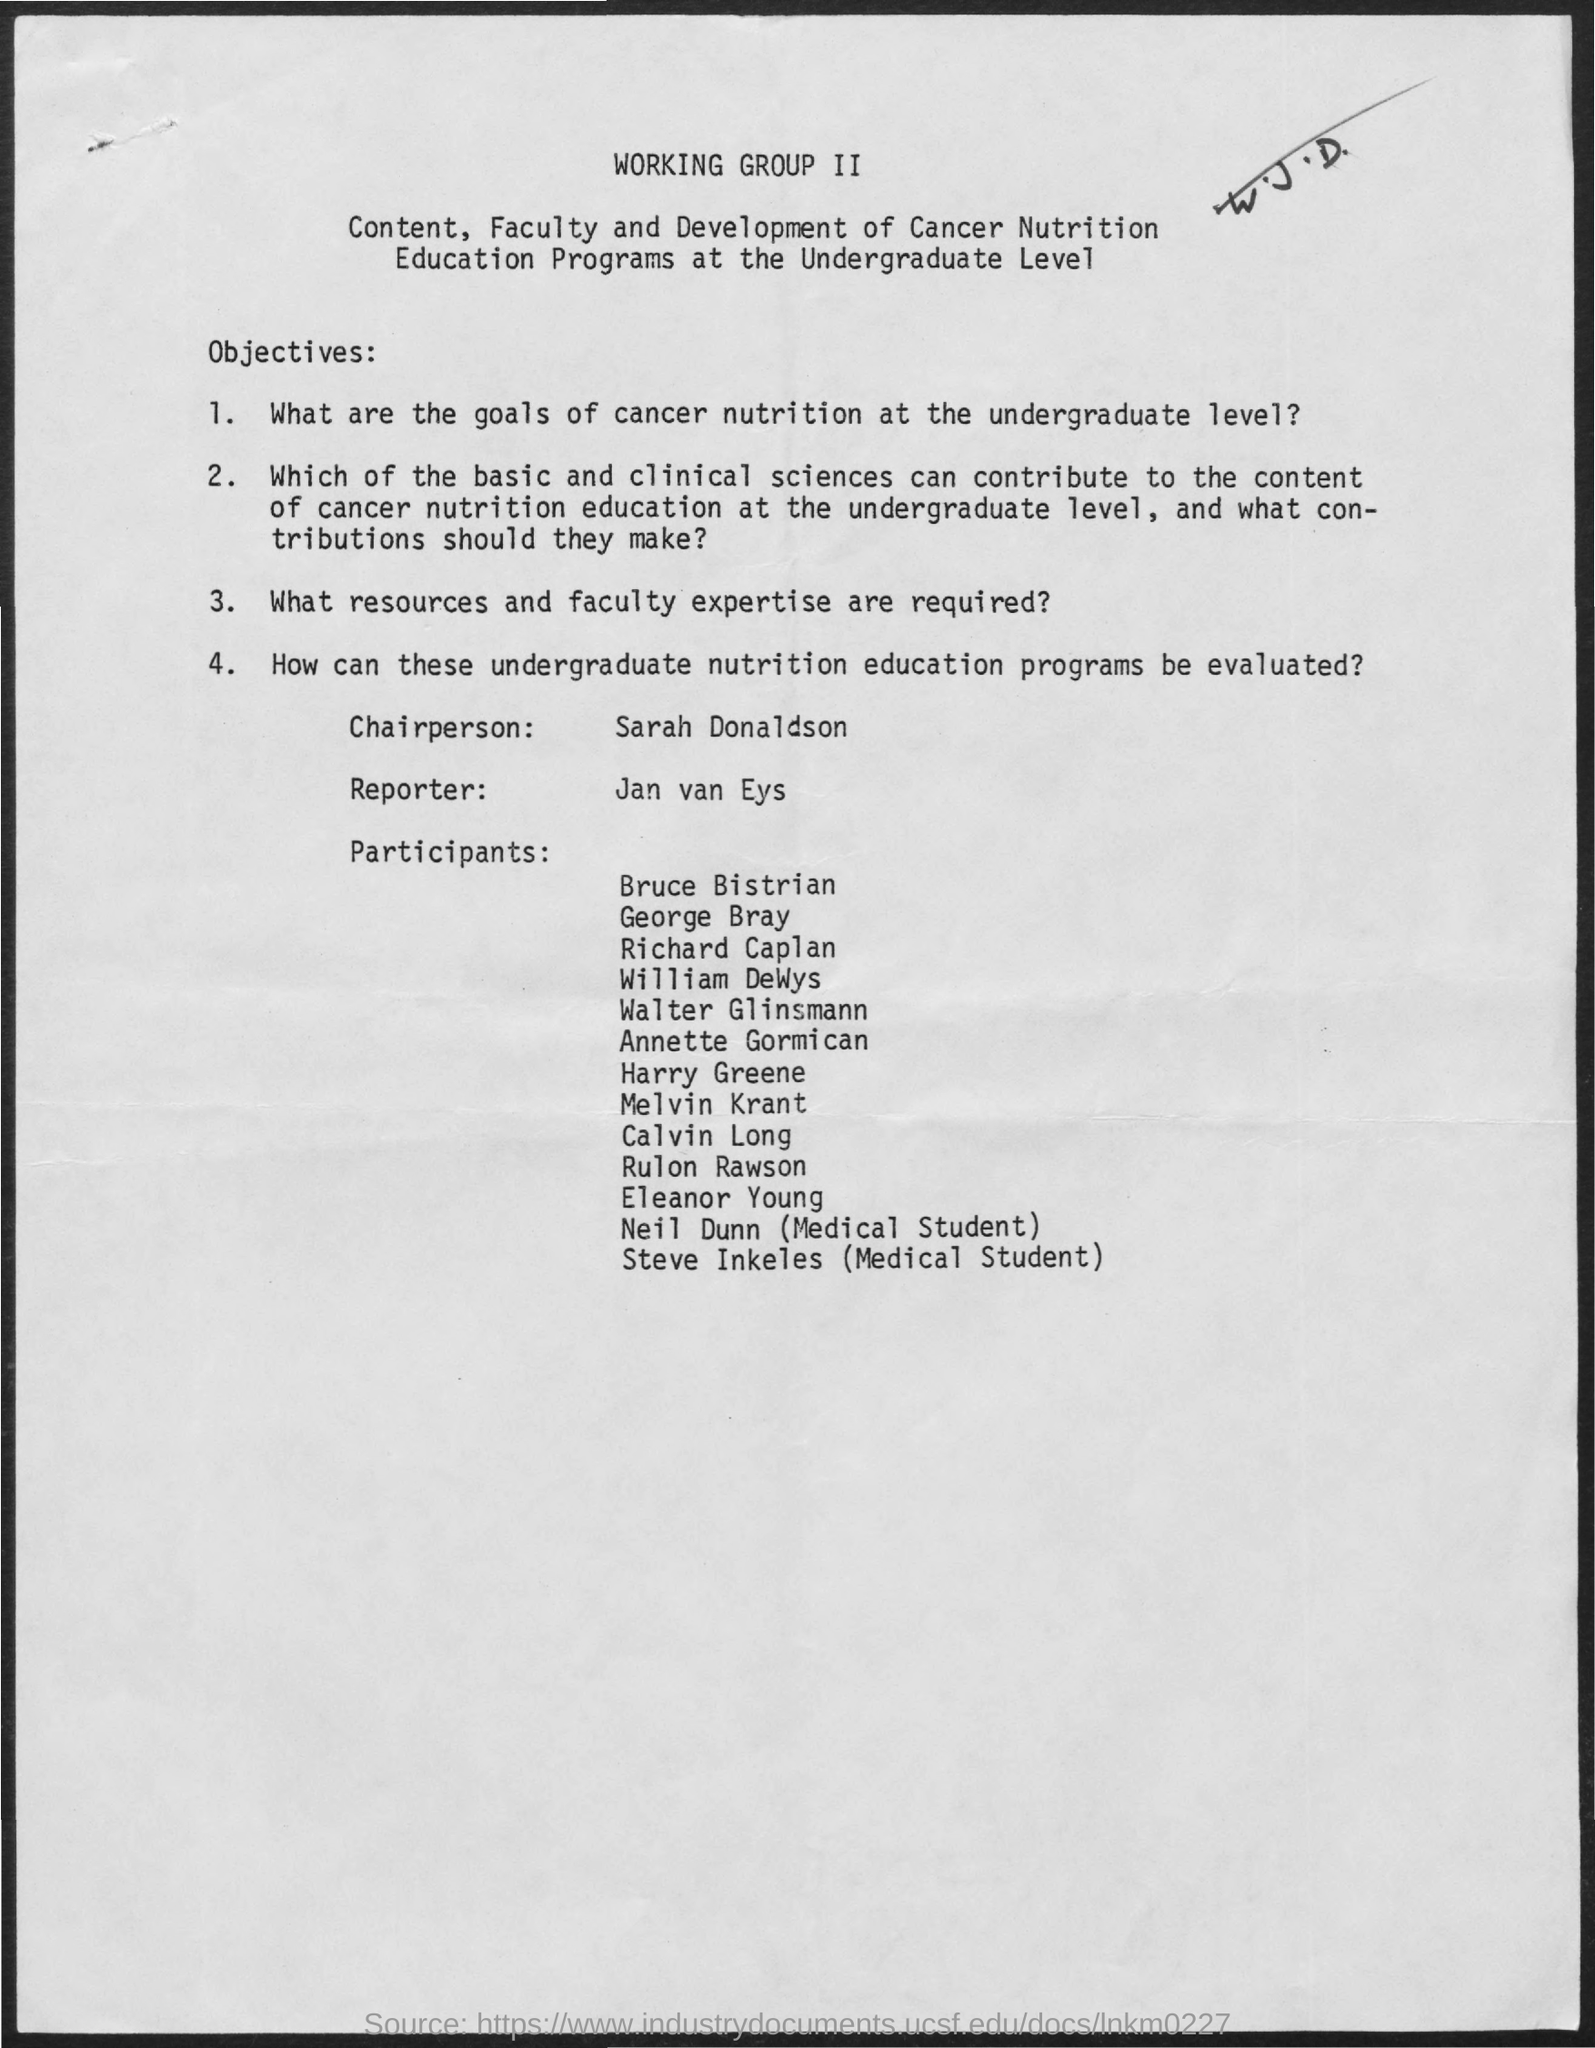List a handful of essential elements in this visual. The reporter mentioned in the given page is Jan van Eys. The chairperson mentioned in the given page is Sarah Donaldson. 